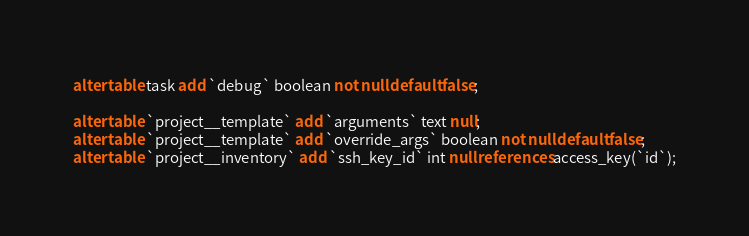<code> <loc_0><loc_0><loc_500><loc_500><_SQL_>alter table task add `debug` boolean not null default false;

alter table `project__template` add `arguments` text null;
alter table `project__template` add `override_args` boolean not null default false;
alter table `project__inventory` add `ssh_key_id` int null references access_key(`id`);</code> 